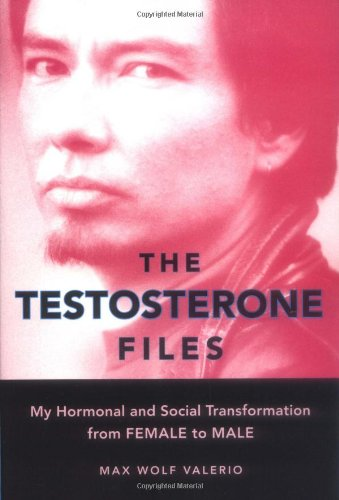What type of book is this? This book is primarily a memoir that delves into gender and identity transformations, often categorized under LGBTQ+ literature. 